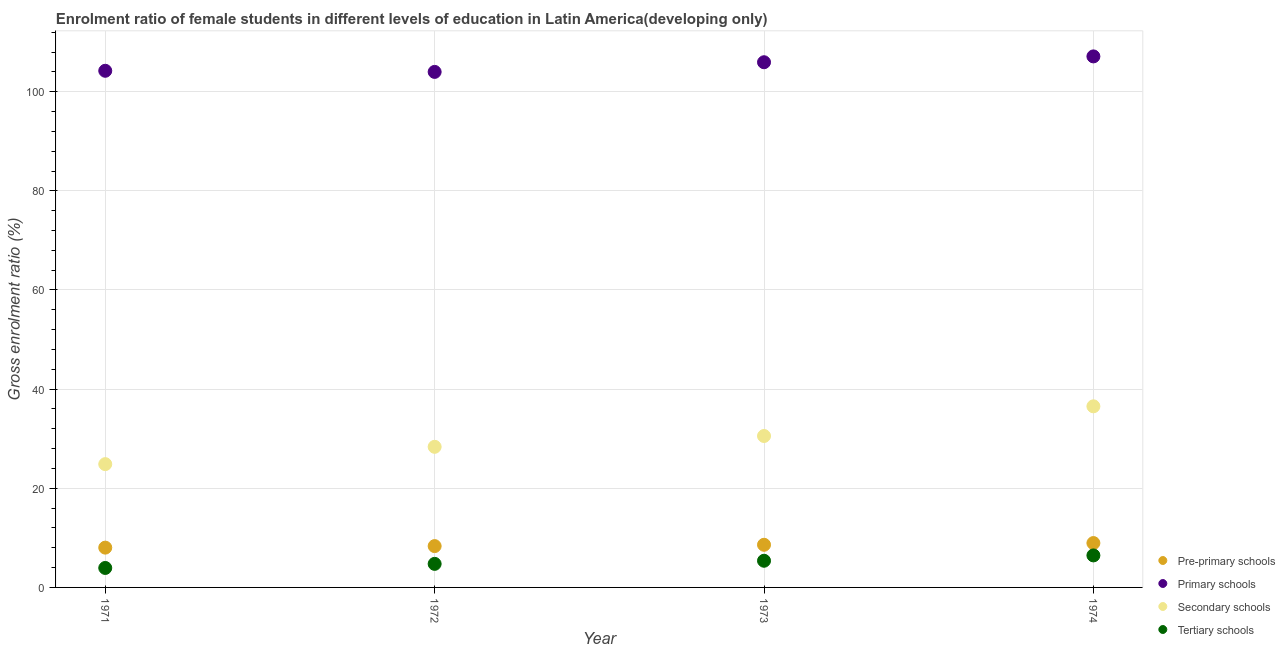How many different coloured dotlines are there?
Provide a succinct answer. 4. What is the gross enrolment ratio(male) in primary schools in 1972?
Provide a short and direct response. 104. Across all years, what is the maximum gross enrolment ratio(male) in pre-primary schools?
Your response must be concise. 8.95. Across all years, what is the minimum gross enrolment ratio(male) in tertiary schools?
Your response must be concise. 3.93. In which year was the gross enrolment ratio(male) in pre-primary schools maximum?
Make the answer very short. 1974. What is the total gross enrolment ratio(male) in tertiary schools in the graph?
Offer a terse response. 20.52. What is the difference between the gross enrolment ratio(male) in primary schools in 1971 and that in 1972?
Your response must be concise. 0.23. What is the difference between the gross enrolment ratio(male) in tertiary schools in 1972 and the gross enrolment ratio(male) in secondary schools in 1973?
Provide a succinct answer. -25.8. What is the average gross enrolment ratio(male) in tertiary schools per year?
Provide a short and direct response. 5.13. In the year 1973, what is the difference between the gross enrolment ratio(male) in tertiary schools and gross enrolment ratio(male) in pre-primary schools?
Your answer should be compact. -3.22. In how many years, is the gross enrolment ratio(male) in primary schools greater than 28 %?
Offer a terse response. 4. What is the ratio of the gross enrolment ratio(male) in pre-primary schools in 1971 to that in 1974?
Provide a short and direct response. 0.9. Is the gross enrolment ratio(male) in secondary schools in 1973 less than that in 1974?
Provide a succinct answer. Yes. Is the difference between the gross enrolment ratio(male) in tertiary schools in 1972 and 1974 greater than the difference between the gross enrolment ratio(male) in secondary schools in 1972 and 1974?
Your response must be concise. Yes. What is the difference between the highest and the second highest gross enrolment ratio(male) in primary schools?
Ensure brevity in your answer.  1.18. What is the difference between the highest and the lowest gross enrolment ratio(male) in primary schools?
Give a very brief answer. 3.13. Is the sum of the gross enrolment ratio(male) in tertiary schools in 1973 and 1974 greater than the maximum gross enrolment ratio(male) in pre-primary schools across all years?
Ensure brevity in your answer.  Yes. Is it the case that in every year, the sum of the gross enrolment ratio(male) in pre-primary schools and gross enrolment ratio(male) in primary schools is greater than the gross enrolment ratio(male) in secondary schools?
Ensure brevity in your answer.  Yes. How many dotlines are there?
Provide a short and direct response. 4. How many years are there in the graph?
Keep it short and to the point. 4. What is the difference between two consecutive major ticks on the Y-axis?
Provide a short and direct response. 20. Does the graph contain any zero values?
Provide a short and direct response. No. Does the graph contain grids?
Give a very brief answer. Yes. Where does the legend appear in the graph?
Offer a very short reply. Bottom right. How many legend labels are there?
Ensure brevity in your answer.  4. What is the title of the graph?
Your answer should be very brief. Enrolment ratio of female students in different levels of education in Latin America(developing only). Does "Efficiency of custom clearance process" appear as one of the legend labels in the graph?
Keep it short and to the point. No. What is the label or title of the X-axis?
Your answer should be compact. Year. What is the Gross enrolment ratio (%) in Pre-primary schools in 1971?
Provide a succinct answer. 8.03. What is the Gross enrolment ratio (%) in Primary schools in 1971?
Your response must be concise. 104.22. What is the Gross enrolment ratio (%) of Secondary schools in 1971?
Offer a terse response. 24.87. What is the Gross enrolment ratio (%) of Tertiary schools in 1971?
Your answer should be very brief. 3.93. What is the Gross enrolment ratio (%) in Pre-primary schools in 1972?
Your answer should be very brief. 8.34. What is the Gross enrolment ratio (%) in Primary schools in 1972?
Make the answer very short. 104. What is the Gross enrolment ratio (%) of Secondary schools in 1972?
Provide a short and direct response. 28.37. What is the Gross enrolment ratio (%) in Tertiary schools in 1972?
Provide a succinct answer. 4.75. What is the Gross enrolment ratio (%) of Pre-primary schools in 1973?
Ensure brevity in your answer.  8.6. What is the Gross enrolment ratio (%) in Primary schools in 1973?
Make the answer very short. 105.94. What is the Gross enrolment ratio (%) of Secondary schools in 1973?
Provide a succinct answer. 30.55. What is the Gross enrolment ratio (%) in Tertiary schools in 1973?
Ensure brevity in your answer.  5.38. What is the Gross enrolment ratio (%) in Pre-primary schools in 1974?
Offer a very short reply. 8.95. What is the Gross enrolment ratio (%) of Primary schools in 1974?
Your answer should be compact. 107.12. What is the Gross enrolment ratio (%) of Secondary schools in 1974?
Provide a short and direct response. 36.53. What is the Gross enrolment ratio (%) of Tertiary schools in 1974?
Your response must be concise. 6.46. Across all years, what is the maximum Gross enrolment ratio (%) of Pre-primary schools?
Make the answer very short. 8.95. Across all years, what is the maximum Gross enrolment ratio (%) in Primary schools?
Offer a very short reply. 107.12. Across all years, what is the maximum Gross enrolment ratio (%) of Secondary schools?
Offer a very short reply. 36.53. Across all years, what is the maximum Gross enrolment ratio (%) in Tertiary schools?
Give a very brief answer. 6.46. Across all years, what is the minimum Gross enrolment ratio (%) of Pre-primary schools?
Offer a terse response. 8.03. Across all years, what is the minimum Gross enrolment ratio (%) in Primary schools?
Your answer should be very brief. 104. Across all years, what is the minimum Gross enrolment ratio (%) of Secondary schools?
Ensure brevity in your answer.  24.87. Across all years, what is the minimum Gross enrolment ratio (%) in Tertiary schools?
Make the answer very short. 3.93. What is the total Gross enrolment ratio (%) of Pre-primary schools in the graph?
Keep it short and to the point. 33.92. What is the total Gross enrolment ratio (%) of Primary schools in the graph?
Your response must be concise. 421.28. What is the total Gross enrolment ratio (%) of Secondary schools in the graph?
Provide a short and direct response. 120.32. What is the total Gross enrolment ratio (%) in Tertiary schools in the graph?
Offer a terse response. 20.52. What is the difference between the Gross enrolment ratio (%) of Pre-primary schools in 1971 and that in 1972?
Provide a succinct answer. -0.31. What is the difference between the Gross enrolment ratio (%) of Primary schools in 1971 and that in 1972?
Ensure brevity in your answer.  0.23. What is the difference between the Gross enrolment ratio (%) in Secondary schools in 1971 and that in 1972?
Ensure brevity in your answer.  -3.49. What is the difference between the Gross enrolment ratio (%) of Tertiary schools in 1971 and that in 1972?
Your answer should be very brief. -0.83. What is the difference between the Gross enrolment ratio (%) of Pre-primary schools in 1971 and that in 1973?
Your response must be concise. -0.57. What is the difference between the Gross enrolment ratio (%) of Primary schools in 1971 and that in 1973?
Offer a terse response. -1.72. What is the difference between the Gross enrolment ratio (%) in Secondary schools in 1971 and that in 1973?
Keep it short and to the point. -5.68. What is the difference between the Gross enrolment ratio (%) in Tertiary schools in 1971 and that in 1973?
Give a very brief answer. -1.45. What is the difference between the Gross enrolment ratio (%) of Pre-primary schools in 1971 and that in 1974?
Keep it short and to the point. -0.92. What is the difference between the Gross enrolment ratio (%) of Primary schools in 1971 and that in 1974?
Ensure brevity in your answer.  -2.9. What is the difference between the Gross enrolment ratio (%) in Secondary schools in 1971 and that in 1974?
Offer a very short reply. -11.66. What is the difference between the Gross enrolment ratio (%) of Tertiary schools in 1971 and that in 1974?
Provide a short and direct response. -2.53. What is the difference between the Gross enrolment ratio (%) of Pre-primary schools in 1972 and that in 1973?
Offer a terse response. -0.26. What is the difference between the Gross enrolment ratio (%) in Primary schools in 1972 and that in 1973?
Give a very brief answer. -1.95. What is the difference between the Gross enrolment ratio (%) in Secondary schools in 1972 and that in 1973?
Your answer should be compact. -2.18. What is the difference between the Gross enrolment ratio (%) of Tertiary schools in 1972 and that in 1973?
Provide a succinct answer. -0.63. What is the difference between the Gross enrolment ratio (%) in Pre-primary schools in 1972 and that in 1974?
Make the answer very short. -0.61. What is the difference between the Gross enrolment ratio (%) in Primary schools in 1972 and that in 1974?
Ensure brevity in your answer.  -3.13. What is the difference between the Gross enrolment ratio (%) in Secondary schools in 1972 and that in 1974?
Make the answer very short. -8.17. What is the difference between the Gross enrolment ratio (%) of Tertiary schools in 1972 and that in 1974?
Provide a short and direct response. -1.71. What is the difference between the Gross enrolment ratio (%) of Pre-primary schools in 1973 and that in 1974?
Provide a short and direct response. -0.35. What is the difference between the Gross enrolment ratio (%) of Primary schools in 1973 and that in 1974?
Offer a terse response. -1.18. What is the difference between the Gross enrolment ratio (%) in Secondary schools in 1973 and that in 1974?
Offer a terse response. -5.99. What is the difference between the Gross enrolment ratio (%) in Tertiary schools in 1973 and that in 1974?
Offer a very short reply. -1.08. What is the difference between the Gross enrolment ratio (%) in Pre-primary schools in 1971 and the Gross enrolment ratio (%) in Primary schools in 1972?
Your answer should be very brief. -95.97. What is the difference between the Gross enrolment ratio (%) of Pre-primary schools in 1971 and the Gross enrolment ratio (%) of Secondary schools in 1972?
Your answer should be very brief. -20.34. What is the difference between the Gross enrolment ratio (%) in Pre-primary schools in 1971 and the Gross enrolment ratio (%) in Tertiary schools in 1972?
Give a very brief answer. 3.28. What is the difference between the Gross enrolment ratio (%) in Primary schools in 1971 and the Gross enrolment ratio (%) in Secondary schools in 1972?
Your answer should be very brief. 75.86. What is the difference between the Gross enrolment ratio (%) in Primary schools in 1971 and the Gross enrolment ratio (%) in Tertiary schools in 1972?
Keep it short and to the point. 99.47. What is the difference between the Gross enrolment ratio (%) in Secondary schools in 1971 and the Gross enrolment ratio (%) in Tertiary schools in 1972?
Your answer should be very brief. 20.12. What is the difference between the Gross enrolment ratio (%) in Pre-primary schools in 1971 and the Gross enrolment ratio (%) in Primary schools in 1973?
Your response must be concise. -97.92. What is the difference between the Gross enrolment ratio (%) of Pre-primary schools in 1971 and the Gross enrolment ratio (%) of Secondary schools in 1973?
Your answer should be very brief. -22.52. What is the difference between the Gross enrolment ratio (%) of Pre-primary schools in 1971 and the Gross enrolment ratio (%) of Tertiary schools in 1973?
Keep it short and to the point. 2.65. What is the difference between the Gross enrolment ratio (%) of Primary schools in 1971 and the Gross enrolment ratio (%) of Secondary schools in 1973?
Ensure brevity in your answer.  73.67. What is the difference between the Gross enrolment ratio (%) in Primary schools in 1971 and the Gross enrolment ratio (%) in Tertiary schools in 1973?
Make the answer very short. 98.84. What is the difference between the Gross enrolment ratio (%) of Secondary schools in 1971 and the Gross enrolment ratio (%) of Tertiary schools in 1973?
Keep it short and to the point. 19.49. What is the difference between the Gross enrolment ratio (%) of Pre-primary schools in 1971 and the Gross enrolment ratio (%) of Primary schools in 1974?
Provide a succinct answer. -99.09. What is the difference between the Gross enrolment ratio (%) in Pre-primary schools in 1971 and the Gross enrolment ratio (%) in Secondary schools in 1974?
Your response must be concise. -28.51. What is the difference between the Gross enrolment ratio (%) of Pre-primary schools in 1971 and the Gross enrolment ratio (%) of Tertiary schools in 1974?
Your response must be concise. 1.57. What is the difference between the Gross enrolment ratio (%) of Primary schools in 1971 and the Gross enrolment ratio (%) of Secondary schools in 1974?
Your response must be concise. 67.69. What is the difference between the Gross enrolment ratio (%) of Primary schools in 1971 and the Gross enrolment ratio (%) of Tertiary schools in 1974?
Provide a succinct answer. 97.76. What is the difference between the Gross enrolment ratio (%) of Secondary schools in 1971 and the Gross enrolment ratio (%) of Tertiary schools in 1974?
Provide a short and direct response. 18.41. What is the difference between the Gross enrolment ratio (%) of Pre-primary schools in 1972 and the Gross enrolment ratio (%) of Primary schools in 1973?
Offer a terse response. -97.61. What is the difference between the Gross enrolment ratio (%) of Pre-primary schools in 1972 and the Gross enrolment ratio (%) of Secondary schools in 1973?
Keep it short and to the point. -22.21. What is the difference between the Gross enrolment ratio (%) of Pre-primary schools in 1972 and the Gross enrolment ratio (%) of Tertiary schools in 1973?
Provide a succinct answer. 2.96. What is the difference between the Gross enrolment ratio (%) in Primary schools in 1972 and the Gross enrolment ratio (%) in Secondary schools in 1973?
Provide a short and direct response. 73.45. What is the difference between the Gross enrolment ratio (%) of Primary schools in 1972 and the Gross enrolment ratio (%) of Tertiary schools in 1973?
Your answer should be very brief. 98.62. What is the difference between the Gross enrolment ratio (%) of Secondary schools in 1972 and the Gross enrolment ratio (%) of Tertiary schools in 1973?
Offer a terse response. 22.99. What is the difference between the Gross enrolment ratio (%) of Pre-primary schools in 1972 and the Gross enrolment ratio (%) of Primary schools in 1974?
Offer a very short reply. -98.78. What is the difference between the Gross enrolment ratio (%) of Pre-primary schools in 1972 and the Gross enrolment ratio (%) of Secondary schools in 1974?
Give a very brief answer. -28.2. What is the difference between the Gross enrolment ratio (%) of Pre-primary schools in 1972 and the Gross enrolment ratio (%) of Tertiary schools in 1974?
Your response must be concise. 1.88. What is the difference between the Gross enrolment ratio (%) in Primary schools in 1972 and the Gross enrolment ratio (%) in Secondary schools in 1974?
Ensure brevity in your answer.  67.46. What is the difference between the Gross enrolment ratio (%) in Primary schools in 1972 and the Gross enrolment ratio (%) in Tertiary schools in 1974?
Provide a short and direct response. 97.54. What is the difference between the Gross enrolment ratio (%) of Secondary schools in 1972 and the Gross enrolment ratio (%) of Tertiary schools in 1974?
Provide a short and direct response. 21.91. What is the difference between the Gross enrolment ratio (%) in Pre-primary schools in 1973 and the Gross enrolment ratio (%) in Primary schools in 1974?
Ensure brevity in your answer.  -98.52. What is the difference between the Gross enrolment ratio (%) in Pre-primary schools in 1973 and the Gross enrolment ratio (%) in Secondary schools in 1974?
Offer a very short reply. -27.93. What is the difference between the Gross enrolment ratio (%) of Pre-primary schools in 1973 and the Gross enrolment ratio (%) of Tertiary schools in 1974?
Provide a succinct answer. 2.14. What is the difference between the Gross enrolment ratio (%) in Primary schools in 1973 and the Gross enrolment ratio (%) in Secondary schools in 1974?
Your response must be concise. 69.41. What is the difference between the Gross enrolment ratio (%) of Primary schools in 1973 and the Gross enrolment ratio (%) of Tertiary schools in 1974?
Offer a terse response. 99.49. What is the difference between the Gross enrolment ratio (%) of Secondary schools in 1973 and the Gross enrolment ratio (%) of Tertiary schools in 1974?
Provide a succinct answer. 24.09. What is the average Gross enrolment ratio (%) in Pre-primary schools per year?
Give a very brief answer. 8.48. What is the average Gross enrolment ratio (%) in Primary schools per year?
Make the answer very short. 105.32. What is the average Gross enrolment ratio (%) of Secondary schools per year?
Offer a terse response. 30.08. What is the average Gross enrolment ratio (%) in Tertiary schools per year?
Keep it short and to the point. 5.13. In the year 1971, what is the difference between the Gross enrolment ratio (%) of Pre-primary schools and Gross enrolment ratio (%) of Primary schools?
Ensure brevity in your answer.  -96.19. In the year 1971, what is the difference between the Gross enrolment ratio (%) in Pre-primary schools and Gross enrolment ratio (%) in Secondary schools?
Your response must be concise. -16.84. In the year 1971, what is the difference between the Gross enrolment ratio (%) of Pre-primary schools and Gross enrolment ratio (%) of Tertiary schools?
Ensure brevity in your answer.  4.1. In the year 1971, what is the difference between the Gross enrolment ratio (%) of Primary schools and Gross enrolment ratio (%) of Secondary schools?
Ensure brevity in your answer.  79.35. In the year 1971, what is the difference between the Gross enrolment ratio (%) in Primary schools and Gross enrolment ratio (%) in Tertiary schools?
Make the answer very short. 100.3. In the year 1971, what is the difference between the Gross enrolment ratio (%) of Secondary schools and Gross enrolment ratio (%) of Tertiary schools?
Offer a terse response. 20.95. In the year 1972, what is the difference between the Gross enrolment ratio (%) in Pre-primary schools and Gross enrolment ratio (%) in Primary schools?
Your answer should be very brief. -95.66. In the year 1972, what is the difference between the Gross enrolment ratio (%) of Pre-primary schools and Gross enrolment ratio (%) of Secondary schools?
Offer a very short reply. -20.03. In the year 1972, what is the difference between the Gross enrolment ratio (%) of Pre-primary schools and Gross enrolment ratio (%) of Tertiary schools?
Your answer should be compact. 3.59. In the year 1972, what is the difference between the Gross enrolment ratio (%) of Primary schools and Gross enrolment ratio (%) of Secondary schools?
Give a very brief answer. 75.63. In the year 1972, what is the difference between the Gross enrolment ratio (%) in Primary schools and Gross enrolment ratio (%) in Tertiary schools?
Ensure brevity in your answer.  99.24. In the year 1972, what is the difference between the Gross enrolment ratio (%) in Secondary schools and Gross enrolment ratio (%) in Tertiary schools?
Provide a succinct answer. 23.61. In the year 1973, what is the difference between the Gross enrolment ratio (%) of Pre-primary schools and Gross enrolment ratio (%) of Primary schools?
Your response must be concise. -97.34. In the year 1973, what is the difference between the Gross enrolment ratio (%) of Pre-primary schools and Gross enrolment ratio (%) of Secondary schools?
Give a very brief answer. -21.95. In the year 1973, what is the difference between the Gross enrolment ratio (%) in Pre-primary schools and Gross enrolment ratio (%) in Tertiary schools?
Your answer should be compact. 3.22. In the year 1973, what is the difference between the Gross enrolment ratio (%) in Primary schools and Gross enrolment ratio (%) in Secondary schools?
Ensure brevity in your answer.  75.4. In the year 1973, what is the difference between the Gross enrolment ratio (%) in Primary schools and Gross enrolment ratio (%) in Tertiary schools?
Your response must be concise. 100.57. In the year 1973, what is the difference between the Gross enrolment ratio (%) in Secondary schools and Gross enrolment ratio (%) in Tertiary schools?
Your response must be concise. 25.17. In the year 1974, what is the difference between the Gross enrolment ratio (%) of Pre-primary schools and Gross enrolment ratio (%) of Primary schools?
Your answer should be very brief. -98.17. In the year 1974, what is the difference between the Gross enrolment ratio (%) of Pre-primary schools and Gross enrolment ratio (%) of Secondary schools?
Offer a very short reply. -27.58. In the year 1974, what is the difference between the Gross enrolment ratio (%) in Pre-primary schools and Gross enrolment ratio (%) in Tertiary schools?
Your response must be concise. 2.49. In the year 1974, what is the difference between the Gross enrolment ratio (%) in Primary schools and Gross enrolment ratio (%) in Secondary schools?
Your answer should be very brief. 70.59. In the year 1974, what is the difference between the Gross enrolment ratio (%) of Primary schools and Gross enrolment ratio (%) of Tertiary schools?
Give a very brief answer. 100.66. In the year 1974, what is the difference between the Gross enrolment ratio (%) of Secondary schools and Gross enrolment ratio (%) of Tertiary schools?
Give a very brief answer. 30.08. What is the ratio of the Gross enrolment ratio (%) in Pre-primary schools in 1971 to that in 1972?
Your answer should be very brief. 0.96. What is the ratio of the Gross enrolment ratio (%) in Primary schools in 1971 to that in 1972?
Keep it short and to the point. 1. What is the ratio of the Gross enrolment ratio (%) of Secondary schools in 1971 to that in 1972?
Your answer should be compact. 0.88. What is the ratio of the Gross enrolment ratio (%) in Tertiary schools in 1971 to that in 1972?
Ensure brevity in your answer.  0.83. What is the ratio of the Gross enrolment ratio (%) of Pre-primary schools in 1971 to that in 1973?
Ensure brevity in your answer.  0.93. What is the ratio of the Gross enrolment ratio (%) of Primary schools in 1971 to that in 1973?
Provide a succinct answer. 0.98. What is the ratio of the Gross enrolment ratio (%) of Secondary schools in 1971 to that in 1973?
Ensure brevity in your answer.  0.81. What is the ratio of the Gross enrolment ratio (%) in Tertiary schools in 1971 to that in 1973?
Your response must be concise. 0.73. What is the ratio of the Gross enrolment ratio (%) in Pre-primary schools in 1971 to that in 1974?
Keep it short and to the point. 0.9. What is the ratio of the Gross enrolment ratio (%) of Primary schools in 1971 to that in 1974?
Give a very brief answer. 0.97. What is the ratio of the Gross enrolment ratio (%) of Secondary schools in 1971 to that in 1974?
Offer a very short reply. 0.68. What is the ratio of the Gross enrolment ratio (%) of Tertiary schools in 1971 to that in 1974?
Offer a terse response. 0.61. What is the ratio of the Gross enrolment ratio (%) in Pre-primary schools in 1972 to that in 1973?
Make the answer very short. 0.97. What is the ratio of the Gross enrolment ratio (%) of Primary schools in 1972 to that in 1973?
Your response must be concise. 0.98. What is the ratio of the Gross enrolment ratio (%) of Tertiary schools in 1972 to that in 1973?
Provide a short and direct response. 0.88. What is the ratio of the Gross enrolment ratio (%) in Pre-primary schools in 1972 to that in 1974?
Ensure brevity in your answer.  0.93. What is the ratio of the Gross enrolment ratio (%) in Primary schools in 1972 to that in 1974?
Provide a short and direct response. 0.97. What is the ratio of the Gross enrolment ratio (%) of Secondary schools in 1972 to that in 1974?
Provide a succinct answer. 0.78. What is the ratio of the Gross enrolment ratio (%) of Tertiary schools in 1972 to that in 1974?
Offer a terse response. 0.74. What is the ratio of the Gross enrolment ratio (%) in Primary schools in 1973 to that in 1974?
Your response must be concise. 0.99. What is the ratio of the Gross enrolment ratio (%) of Secondary schools in 1973 to that in 1974?
Your answer should be very brief. 0.84. What is the ratio of the Gross enrolment ratio (%) in Tertiary schools in 1973 to that in 1974?
Offer a terse response. 0.83. What is the difference between the highest and the second highest Gross enrolment ratio (%) of Pre-primary schools?
Make the answer very short. 0.35. What is the difference between the highest and the second highest Gross enrolment ratio (%) in Primary schools?
Your answer should be compact. 1.18. What is the difference between the highest and the second highest Gross enrolment ratio (%) in Secondary schools?
Offer a terse response. 5.99. What is the difference between the highest and the second highest Gross enrolment ratio (%) in Tertiary schools?
Offer a very short reply. 1.08. What is the difference between the highest and the lowest Gross enrolment ratio (%) in Pre-primary schools?
Your answer should be very brief. 0.92. What is the difference between the highest and the lowest Gross enrolment ratio (%) in Primary schools?
Provide a short and direct response. 3.13. What is the difference between the highest and the lowest Gross enrolment ratio (%) in Secondary schools?
Your answer should be very brief. 11.66. What is the difference between the highest and the lowest Gross enrolment ratio (%) of Tertiary schools?
Offer a terse response. 2.53. 